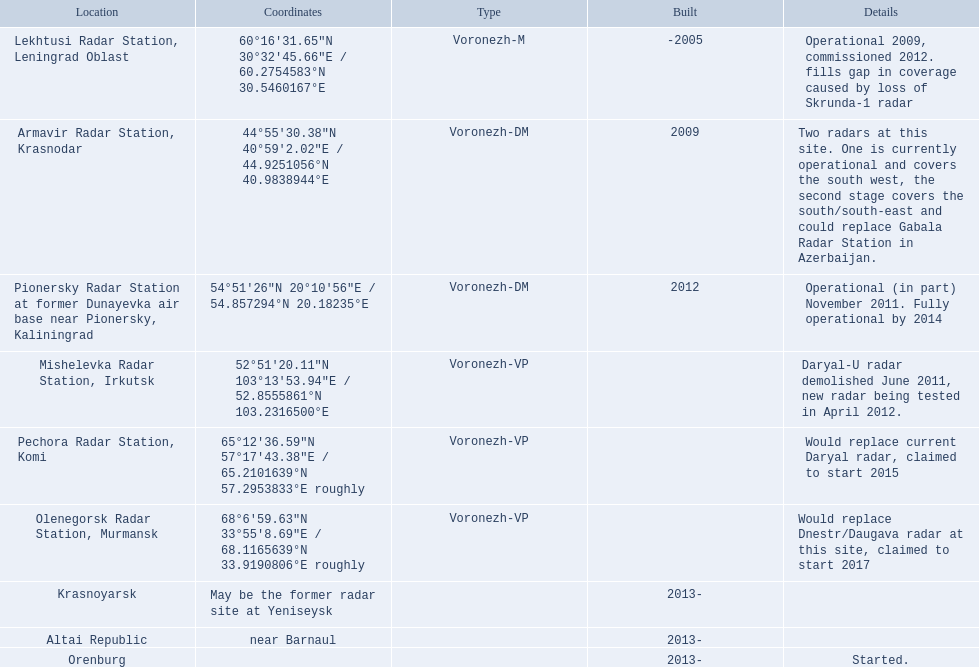What is the location of each radar? Lekhtusi Radar Station, Leningrad Oblast, Armavir Radar Station, Krasnodar, Pionersky Radar Station at former Dunayevka air base near Pionersky, Kaliningrad, Mishelevka Radar Station, Irkutsk, Pechora Radar Station, Komi, Olenegorsk Radar Station, Murmansk, Krasnoyarsk, Altai Republic, Orenburg. Can you provide information about each radar? Operational 2009, commissioned 2012. fills gap in coverage caused by loss of Skrunda-1 radar, Two radars at this site. One is currently operational and covers the south west, the second stage covers the south/south-east and could replace Gabala Radar Station in Azerbaijan., Operational (in part) November 2011. Fully operational by 2014, Daryal-U radar demolished June 2011, new radar being tested in April 2012., Would replace current Daryal radar, claimed to start 2015, Would replace Dnestr/Daugava radar at this site, claimed to start 2017, , , Started. Which radar was planned to begin in 2015? Pechora Radar Station, Komi. Can you list all the locations? Lekhtusi Radar Station, Leningrad Oblast, Armavir Radar Station, Krasnodar, Pionersky Radar Station at former Dunayevka air base near Pionersky, Kaliningrad, Mishelevka Radar Station, Irkutsk, Pechora Radar Station, Komi, Olenegorsk Radar Station, Murmansk, Krasnoyarsk, Altai Republic, Orenburg. Also, which location corresponds to 60deg16'31.65''n 30deg32'45.66''e / 60.2754583degn 30.5460167dege coordinates? Lekhtusi Radar Station, Leningrad Oblast. Where are the locations of voronezh radar? Lekhtusi Radar Station, Leningrad Oblast, Armavir Radar Station, Krasnodar, Pionersky Radar Station at former Dunayevka air base near Pionersky, Kaliningrad, Mishelevka Radar Station, Irkutsk, Pechora Radar Station, Komi, Olenegorsk Radar Station, Murmansk, Krasnoyarsk, Altai Republic, Orenburg. Among these locations, which ones have known coordinates? Lekhtusi Radar Station, Leningrad Oblast, Armavir Radar Station, Krasnodar, Pionersky Radar Station at former Dunayevka air base near Pionersky, Kaliningrad, Mishelevka Radar Station, Irkutsk, Pechora Radar Station, Komi, Olenegorsk Radar Station, Murmansk. Which location has coordinates 60°16'31.65"n 30°32'45.66"e / 60.2754583°n 30.5460167°e? Lekhtusi Radar Station, Leningrad Oblast. 